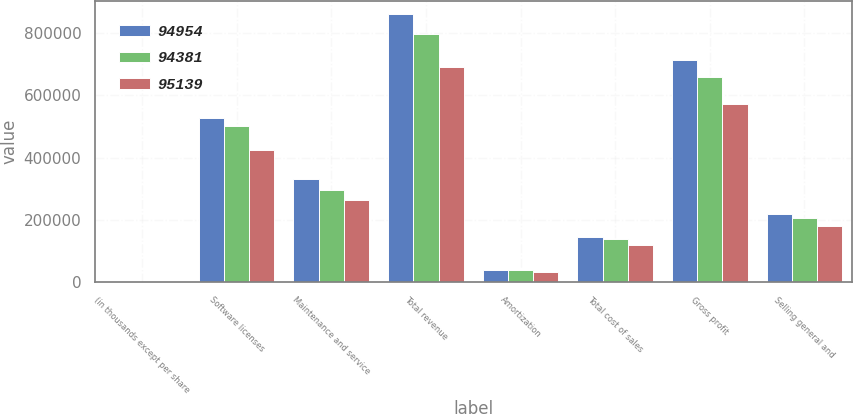<chart> <loc_0><loc_0><loc_500><loc_500><stacked_bar_chart><ecel><fcel>(in thousands except per share<fcel>Software licenses<fcel>Maintenance and service<fcel>Total revenue<fcel>Amortization<fcel>Total cost of sales<fcel>Gross profit<fcel>Selling general and<nl><fcel>94954<fcel>2013<fcel>528944<fcel>332316<fcel>861260<fcel>38298<fcel>146692<fcel>714568<fcel>218907<nl><fcel>94381<fcel>2012<fcel>501870<fcel>296148<fcel>798018<fcel>40889<fcel>139516<fcel>658502<fcel>205178<nl><fcel>95139<fcel>2011<fcel>425881<fcel>265568<fcel>691449<fcel>33728<fcel>119014<fcel>572435<fcel>180357<nl></chart> 